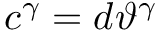<formula> <loc_0><loc_0><loc_500><loc_500>c ^ { \gamma } = d \vartheta ^ { \gamma }</formula> 